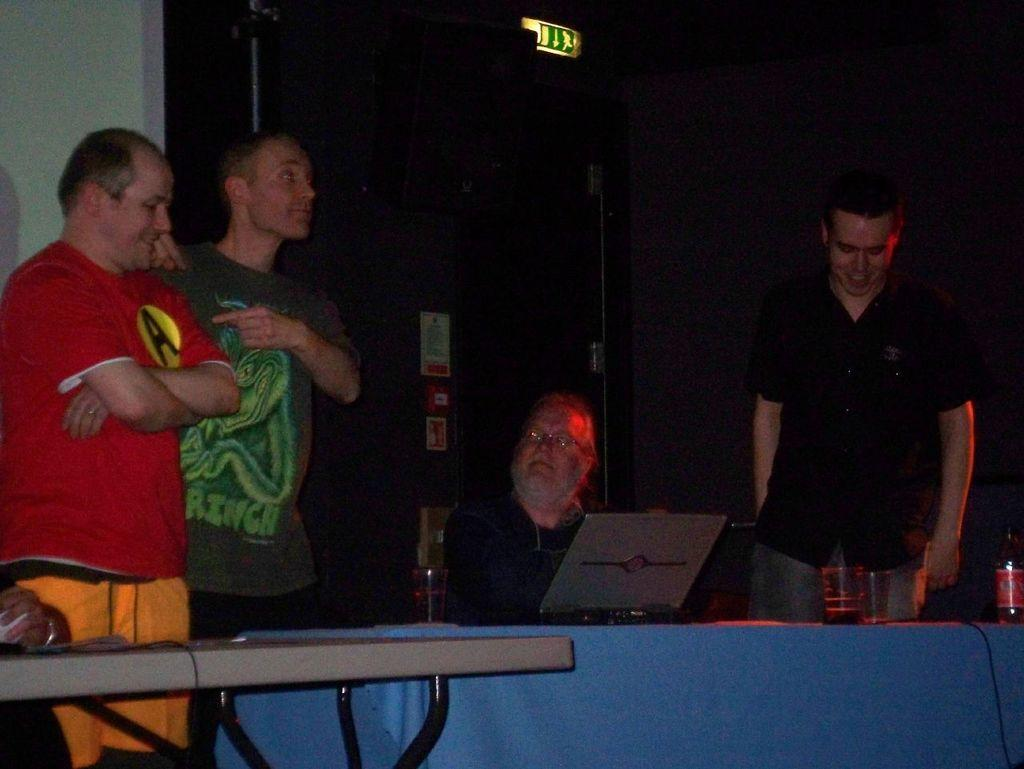How many people are present in the image? There are three persons standing in the image. What is the man in the image doing? The man is sitting in front of a table. What objects are on the table? There is a laptop, a glass, and a bottle on the table. What type of hen can be seen knitting with yarn in the image? There is no hen or yarn present in the image. How does the number of people in the image increase over time? The number of people in the image does not increase over time, as the image is a static representation. 